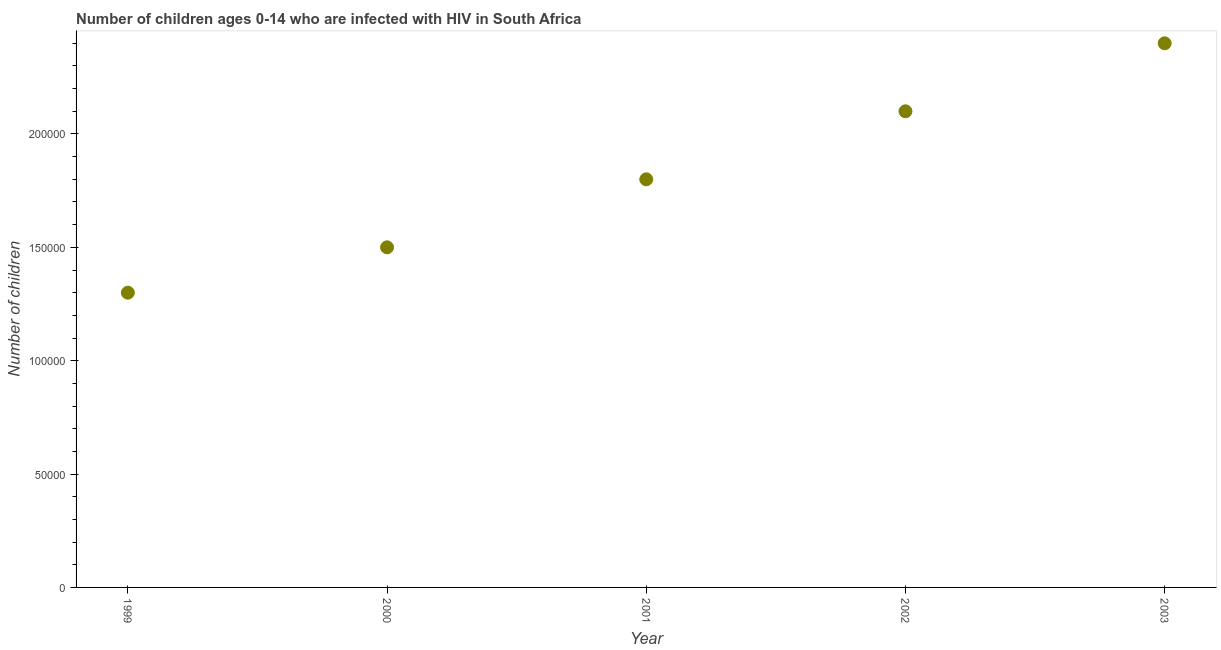What is the number of children living with hiv in 2000?
Make the answer very short. 1.50e+05. Across all years, what is the maximum number of children living with hiv?
Your answer should be very brief. 2.40e+05. Across all years, what is the minimum number of children living with hiv?
Offer a very short reply. 1.30e+05. What is the sum of the number of children living with hiv?
Keep it short and to the point. 9.10e+05. What is the difference between the number of children living with hiv in 2002 and 2003?
Provide a succinct answer. -3.00e+04. What is the average number of children living with hiv per year?
Give a very brief answer. 1.82e+05. In how many years, is the number of children living with hiv greater than 190000 ?
Offer a terse response. 2. Do a majority of the years between 1999 and 2003 (inclusive) have number of children living with hiv greater than 170000 ?
Your answer should be compact. Yes. What is the ratio of the number of children living with hiv in 1999 to that in 2003?
Offer a terse response. 0.54. Is the number of children living with hiv in 2000 less than that in 2002?
Keep it short and to the point. Yes. Is the difference between the number of children living with hiv in 1999 and 2003 greater than the difference between any two years?
Offer a very short reply. Yes. What is the difference between the highest and the second highest number of children living with hiv?
Keep it short and to the point. 3.00e+04. Is the sum of the number of children living with hiv in 2002 and 2003 greater than the maximum number of children living with hiv across all years?
Your response must be concise. Yes. What is the difference between the highest and the lowest number of children living with hiv?
Ensure brevity in your answer.  1.10e+05. In how many years, is the number of children living with hiv greater than the average number of children living with hiv taken over all years?
Ensure brevity in your answer.  2. Does the number of children living with hiv monotonically increase over the years?
Your answer should be compact. Yes. How many dotlines are there?
Offer a very short reply. 1. Are the values on the major ticks of Y-axis written in scientific E-notation?
Your answer should be compact. No. Does the graph contain any zero values?
Give a very brief answer. No. What is the title of the graph?
Your answer should be compact. Number of children ages 0-14 who are infected with HIV in South Africa. What is the label or title of the Y-axis?
Your answer should be very brief. Number of children. What is the Number of children in 1999?
Keep it short and to the point. 1.30e+05. What is the Number of children in 2002?
Make the answer very short. 2.10e+05. What is the difference between the Number of children in 1999 and 2000?
Your answer should be very brief. -2.00e+04. What is the difference between the Number of children in 1999 and 2002?
Offer a terse response. -8.00e+04. What is the difference between the Number of children in 1999 and 2003?
Ensure brevity in your answer.  -1.10e+05. What is the difference between the Number of children in 2000 and 2002?
Ensure brevity in your answer.  -6.00e+04. What is the difference between the Number of children in 2000 and 2003?
Provide a succinct answer. -9.00e+04. What is the difference between the Number of children in 2001 and 2003?
Give a very brief answer. -6.00e+04. What is the ratio of the Number of children in 1999 to that in 2000?
Provide a succinct answer. 0.87. What is the ratio of the Number of children in 1999 to that in 2001?
Your response must be concise. 0.72. What is the ratio of the Number of children in 1999 to that in 2002?
Your answer should be compact. 0.62. What is the ratio of the Number of children in 1999 to that in 2003?
Provide a succinct answer. 0.54. What is the ratio of the Number of children in 2000 to that in 2001?
Provide a succinct answer. 0.83. What is the ratio of the Number of children in 2000 to that in 2002?
Give a very brief answer. 0.71. What is the ratio of the Number of children in 2000 to that in 2003?
Keep it short and to the point. 0.62. What is the ratio of the Number of children in 2001 to that in 2002?
Your answer should be compact. 0.86. What is the ratio of the Number of children in 2002 to that in 2003?
Your answer should be compact. 0.88. 